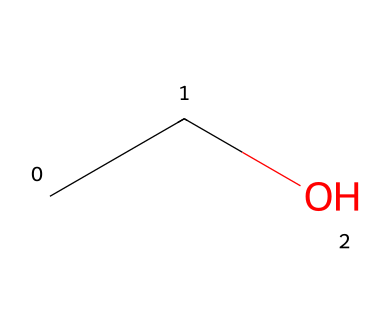What is the molecular formula of this compound? The chemical structure (CCO) shows two carbon atoms (C) and you can count the number of oxygen atoms (O) present, which is one. Therefore, the molecular formula combines these elements.
Answer: C2H6O How many total atoms are present in this compound? The structure has two carbon atoms (C), six hydrogen atoms (H), and one oxygen atom (O). Adding all the atoms together gives a total of nine atoms.
Answer: 9 What type of isomerism can occur with this molecule? The structure depicts ethanol, which can exhibit geometric isomerism due to the presence of a carbon-carbon single bond. However, being a simple molecule, it mainly shows structural isomerism rather than geometric isomerism.
Answer: structural How many hydrogen bonds can ethanol typically form? Each ethanol molecule can form hydrogen bonds with others due to the presence of an oxygen atom and hydrogen atoms attached to it. Each hydroxyl group (OH) can form one hydrogen bond.
Answer: 3 Can this compound exist in geometric isomer forms? While ethanol itself does not typically exhibit geometric isomerism because there are no restricted rotations or double bonds, it is important to connect the concept of isomerism in more complex spirits. Thus, it showcases how isomer forms work in organic chemistry.
Answer: no 